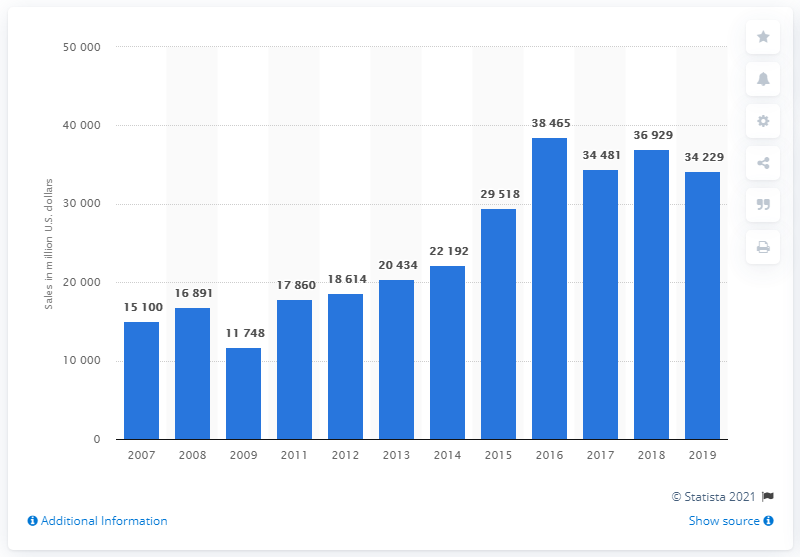Point out several critical features in this image. In 2019, ZF Friedrichshafen AG's global automotive parts sales amounted to approximately 34,229 million US dollars. 